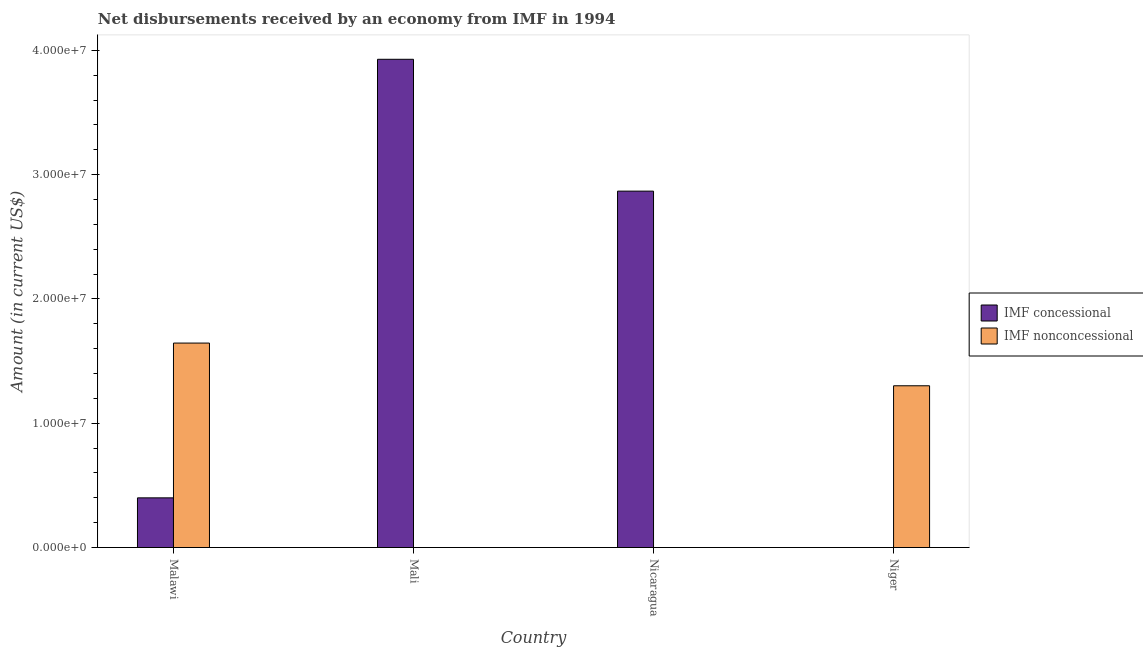How many different coloured bars are there?
Keep it short and to the point. 2. What is the label of the 3rd group of bars from the left?
Offer a terse response. Nicaragua. What is the net non concessional disbursements from imf in Niger?
Ensure brevity in your answer.  1.30e+07. Across all countries, what is the maximum net concessional disbursements from imf?
Offer a very short reply. 3.93e+07. Across all countries, what is the minimum net concessional disbursements from imf?
Offer a terse response. 0. In which country was the net non concessional disbursements from imf maximum?
Your answer should be compact. Malawi. What is the total net non concessional disbursements from imf in the graph?
Offer a terse response. 2.95e+07. What is the difference between the net concessional disbursements from imf in Malawi and that in Nicaragua?
Your answer should be compact. -2.47e+07. What is the difference between the net non concessional disbursements from imf in Malawi and the net concessional disbursements from imf in Nicaragua?
Keep it short and to the point. -1.22e+07. What is the average net concessional disbursements from imf per country?
Give a very brief answer. 1.80e+07. What is the difference between the net non concessional disbursements from imf and net concessional disbursements from imf in Malawi?
Your answer should be very brief. 1.25e+07. In how many countries, is the net non concessional disbursements from imf greater than 4000000 US$?
Make the answer very short. 2. What is the ratio of the net concessional disbursements from imf in Malawi to that in Nicaragua?
Offer a very short reply. 0.14. What is the difference between the highest and the second highest net concessional disbursements from imf?
Ensure brevity in your answer.  1.06e+07. What is the difference between the highest and the lowest net concessional disbursements from imf?
Offer a terse response. 3.93e+07. In how many countries, is the net non concessional disbursements from imf greater than the average net non concessional disbursements from imf taken over all countries?
Ensure brevity in your answer.  2. Is the sum of the net non concessional disbursements from imf in Malawi and Niger greater than the maximum net concessional disbursements from imf across all countries?
Your answer should be very brief. No. How many bars are there?
Your response must be concise. 5. Are all the bars in the graph horizontal?
Your answer should be very brief. No. How many countries are there in the graph?
Your answer should be compact. 4. Are the values on the major ticks of Y-axis written in scientific E-notation?
Provide a short and direct response. Yes. Where does the legend appear in the graph?
Give a very brief answer. Center right. How many legend labels are there?
Your answer should be very brief. 2. What is the title of the graph?
Provide a succinct answer. Net disbursements received by an economy from IMF in 1994. Does "Primary completion rate" appear as one of the legend labels in the graph?
Keep it short and to the point. No. What is the Amount (in current US$) of IMF concessional in Malawi?
Offer a terse response. 4.00e+06. What is the Amount (in current US$) of IMF nonconcessional in Malawi?
Provide a succinct answer. 1.64e+07. What is the Amount (in current US$) in IMF concessional in Mali?
Keep it short and to the point. 3.93e+07. What is the Amount (in current US$) of IMF concessional in Nicaragua?
Provide a short and direct response. 2.87e+07. What is the Amount (in current US$) in IMF concessional in Niger?
Provide a succinct answer. 0. What is the Amount (in current US$) in IMF nonconcessional in Niger?
Provide a succinct answer. 1.30e+07. Across all countries, what is the maximum Amount (in current US$) of IMF concessional?
Provide a succinct answer. 3.93e+07. Across all countries, what is the maximum Amount (in current US$) in IMF nonconcessional?
Ensure brevity in your answer.  1.64e+07. Across all countries, what is the minimum Amount (in current US$) in IMF concessional?
Your response must be concise. 0. Across all countries, what is the minimum Amount (in current US$) in IMF nonconcessional?
Your answer should be very brief. 0. What is the total Amount (in current US$) in IMF concessional in the graph?
Offer a very short reply. 7.19e+07. What is the total Amount (in current US$) in IMF nonconcessional in the graph?
Give a very brief answer. 2.95e+07. What is the difference between the Amount (in current US$) in IMF concessional in Malawi and that in Mali?
Your answer should be compact. -3.53e+07. What is the difference between the Amount (in current US$) of IMF concessional in Malawi and that in Nicaragua?
Make the answer very short. -2.47e+07. What is the difference between the Amount (in current US$) in IMF nonconcessional in Malawi and that in Niger?
Keep it short and to the point. 3.44e+06. What is the difference between the Amount (in current US$) in IMF concessional in Mali and that in Nicaragua?
Provide a succinct answer. 1.06e+07. What is the difference between the Amount (in current US$) of IMF concessional in Malawi and the Amount (in current US$) of IMF nonconcessional in Niger?
Your response must be concise. -9.02e+06. What is the difference between the Amount (in current US$) in IMF concessional in Mali and the Amount (in current US$) in IMF nonconcessional in Niger?
Your response must be concise. 2.63e+07. What is the difference between the Amount (in current US$) in IMF concessional in Nicaragua and the Amount (in current US$) in IMF nonconcessional in Niger?
Provide a succinct answer. 1.57e+07. What is the average Amount (in current US$) of IMF concessional per country?
Provide a succinct answer. 1.80e+07. What is the average Amount (in current US$) in IMF nonconcessional per country?
Your answer should be very brief. 7.36e+06. What is the difference between the Amount (in current US$) in IMF concessional and Amount (in current US$) in IMF nonconcessional in Malawi?
Your answer should be compact. -1.25e+07. What is the ratio of the Amount (in current US$) of IMF concessional in Malawi to that in Mali?
Provide a succinct answer. 0.1. What is the ratio of the Amount (in current US$) in IMF concessional in Malawi to that in Nicaragua?
Provide a short and direct response. 0.14. What is the ratio of the Amount (in current US$) in IMF nonconcessional in Malawi to that in Niger?
Offer a terse response. 1.26. What is the ratio of the Amount (in current US$) of IMF concessional in Mali to that in Nicaragua?
Your answer should be compact. 1.37. What is the difference between the highest and the second highest Amount (in current US$) in IMF concessional?
Keep it short and to the point. 1.06e+07. What is the difference between the highest and the lowest Amount (in current US$) in IMF concessional?
Offer a terse response. 3.93e+07. What is the difference between the highest and the lowest Amount (in current US$) of IMF nonconcessional?
Ensure brevity in your answer.  1.64e+07. 